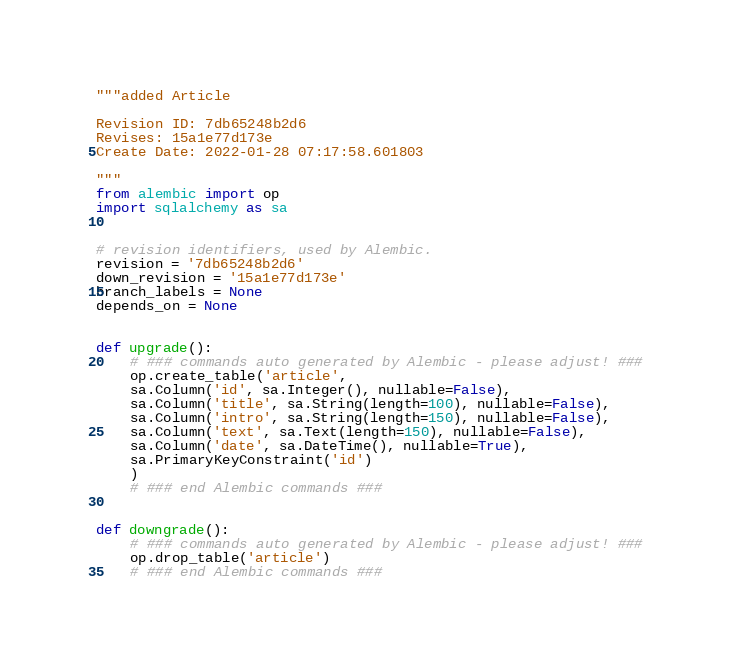<code> <loc_0><loc_0><loc_500><loc_500><_Python_>"""added Article

Revision ID: 7db65248b2d6
Revises: 15a1e77d173e
Create Date: 2022-01-28 07:17:58.601803

"""
from alembic import op
import sqlalchemy as sa


# revision identifiers, used by Alembic.
revision = '7db65248b2d6'
down_revision = '15a1e77d173e'
branch_labels = None
depends_on = None


def upgrade():
    # ### commands auto generated by Alembic - please adjust! ###
    op.create_table('article',
    sa.Column('id', sa.Integer(), nullable=False),
    sa.Column('title', sa.String(length=100), nullable=False),
    sa.Column('intro', sa.String(length=150), nullable=False),
    sa.Column('text', sa.Text(length=150), nullable=False),
    sa.Column('date', sa.DateTime(), nullable=True),
    sa.PrimaryKeyConstraint('id')
    )
    # ### end Alembic commands ###


def downgrade():
    # ### commands auto generated by Alembic - please adjust! ###
    op.drop_table('article')
    # ### end Alembic commands ###
</code> 